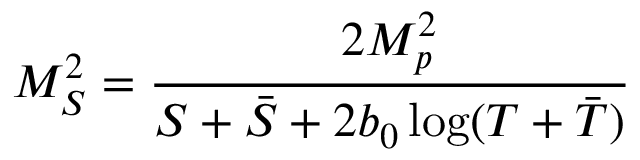<formula> <loc_0><loc_0><loc_500><loc_500>M _ { S } ^ { 2 } = \frac { 2 M _ { p } ^ { 2 } } { S + \bar { S } + 2 b _ { 0 } \log ( T + \bar { T } ) }</formula> 